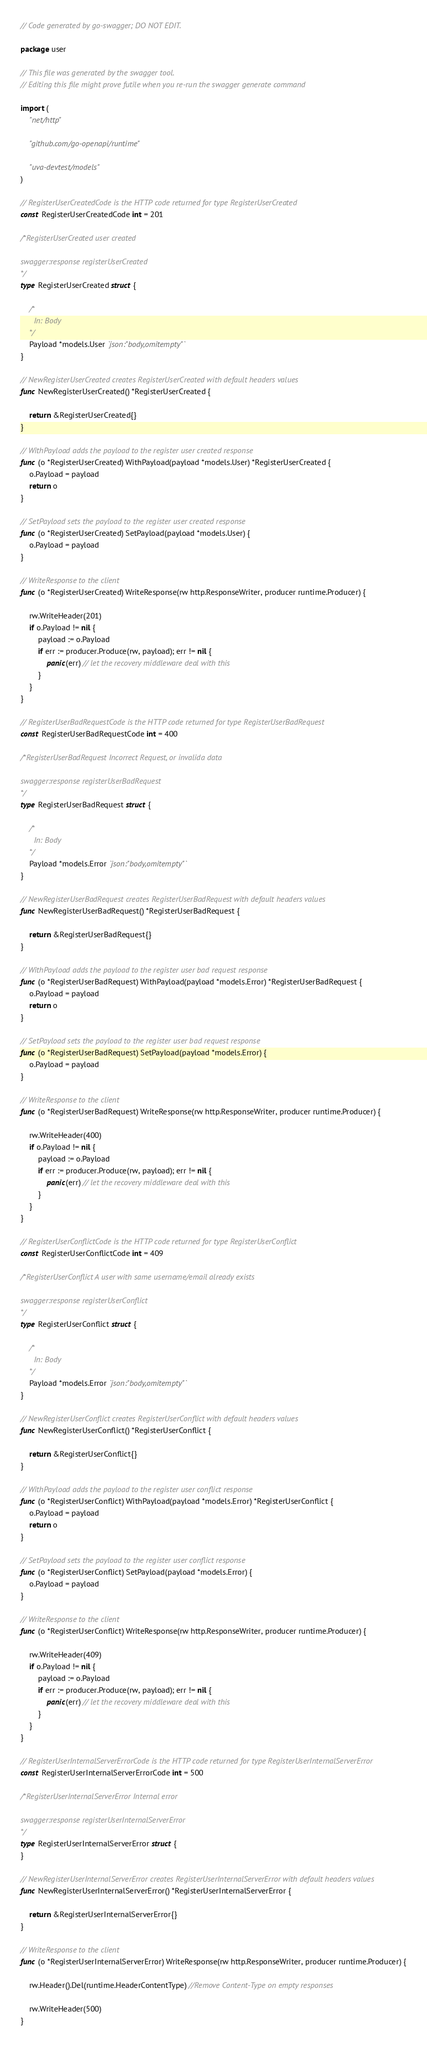<code> <loc_0><loc_0><loc_500><loc_500><_Go_>// Code generated by go-swagger; DO NOT EDIT.

package user

// This file was generated by the swagger tool.
// Editing this file might prove futile when you re-run the swagger generate command

import (
	"net/http"

	"github.com/go-openapi/runtime"

	"uva-devtest/models"
)

// RegisterUserCreatedCode is the HTTP code returned for type RegisterUserCreated
const RegisterUserCreatedCode int = 201

/*RegisterUserCreated user created

swagger:response registerUserCreated
*/
type RegisterUserCreated struct {

	/*
	  In: Body
	*/
	Payload *models.User `json:"body,omitempty"`
}

// NewRegisterUserCreated creates RegisterUserCreated with default headers values
func NewRegisterUserCreated() *RegisterUserCreated {

	return &RegisterUserCreated{}
}

// WithPayload adds the payload to the register user created response
func (o *RegisterUserCreated) WithPayload(payload *models.User) *RegisterUserCreated {
	o.Payload = payload
	return o
}

// SetPayload sets the payload to the register user created response
func (o *RegisterUserCreated) SetPayload(payload *models.User) {
	o.Payload = payload
}

// WriteResponse to the client
func (o *RegisterUserCreated) WriteResponse(rw http.ResponseWriter, producer runtime.Producer) {

	rw.WriteHeader(201)
	if o.Payload != nil {
		payload := o.Payload
		if err := producer.Produce(rw, payload); err != nil {
			panic(err) // let the recovery middleware deal with this
		}
	}
}

// RegisterUserBadRequestCode is the HTTP code returned for type RegisterUserBadRequest
const RegisterUserBadRequestCode int = 400

/*RegisterUserBadRequest Incorrect Request, or invalida data

swagger:response registerUserBadRequest
*/
type RegisterUserBadRequest struct {

	/*
	  In: Body
	*/
	Payload *models.Error `json:"body,omitempty"`
}

// NewRegisterUserBadRequest creates RegisterUserBadRequest with default headers values
func NewRegisterUserBadRequest() *RegisterUserBadRequest {

	return &RegisterUserBadRequest{}
}

// WithPayload adds the payload to the register user bad request response
func (o *RegisterUserBadRequest) WithPayload(payload *models.Error) *RegisterUserBadRequest {
	o.Payload = payload
	return o
}

// SetPayload sets the payload to the register user bad request response
func (o *RegisterUserBadRequest) SetPayload(payload *models.Error) {
	o.Payload = payload
}

// WriteResponse to the client
func (o *RegisterUserBadRequest) WriteResponse(rw http.ResponseWriter, producer runtime.Producer) {

	rw.WriteHeader(400)
	if o.Payload != nil {
		payload := o.Payload
		if err := producer.Produce(rw, payload); err != nil {
			panic(err) // let the recovery middleware deal with this
		}
	}
}

// RegisterUserConflictCode is the HTTP code returned for type RegisterUserConflict
const RegisterUserConflictCode int = 409

/*RegisterUserConflict A user with same username/email already exists

swagger:response registerUserConflict
*/
type RegisterUserConflict struct {

	/*
	  In: Body
	*/
	Payload *models.Error `json:"body,omitempty"`
}

// NewRegisterUserConflict creates RegisterUserConflict with default headers values
func NewRegisterUserConflict() *RegisterUserConflict {

	return &RegisterUserConflict{}
}

// WithPayload adds the payload to the register user conflict response
func (o *RegisterUserConflict) WithPayload(payload *models.Error) *RegisterUserConflict {
	o.Payload = payload
	return o
}

// SetPayload sets the payload to the register user conflict response
func (o *RegisterUserConflict) SetPayload(payload *models.Error) {
	o.Payload = payload
}

// WriteResponse to the client
func (o *RegisterUserConflict) WriteResponse(rw http.ResponseWriter, producer runtime.Producer) {

	rw.WriteHeader(409)
	if o.Payload != nil {
		payload := o.Payload
		if err := producer.Produce(rw, payload); err != nil {
			panic(err) // let the recovery middleware deal with this
		}
	}
}

// RegisterUserInternalServerErrorCode is the HTTP code returned for type RegisterUserInternalServerError
const RegisterUserInternalServerErrorCode int = 500

/*RegisterUserInternalServerError Internal error

swagger:response registerUserInternalServerError
*/
type RegisterUserInternalServerError struct {
}

// NewRegisterUserInternalServerError creates RegisterUserInternalServerError with default headers values
func NewRegisterUserInternalServerError() *RegisterUserInternalServerError {

	return &RegisterUserInternalServerError{}
}

// WriteResponse to the client
func (o *RegisterUserInternalServerError) WriteResponse(rw http.ResponseWriter, producer runtime.Producer) {

	rw.Header().Del(runtime.HeaderContentType) //Remove Content-Type on empty responses

	rw.WriteHeader(500)
}
</code> 